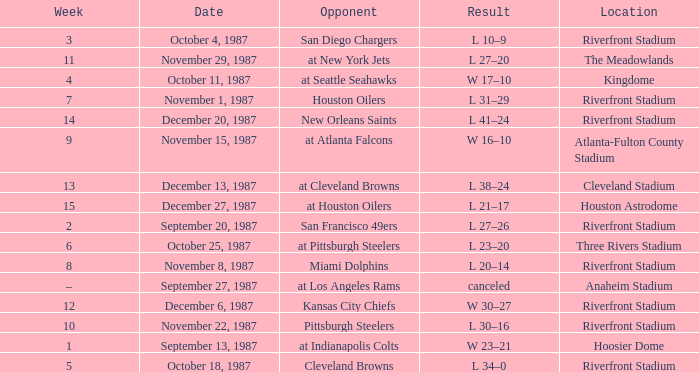What was the result of the game against the Miami Dolphins held at the Riverfront Stadium? L 20–14. 